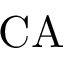Convert formula to latex. <formula><loc_0><loc_0><loc_500><loc_500>C A</formula> 